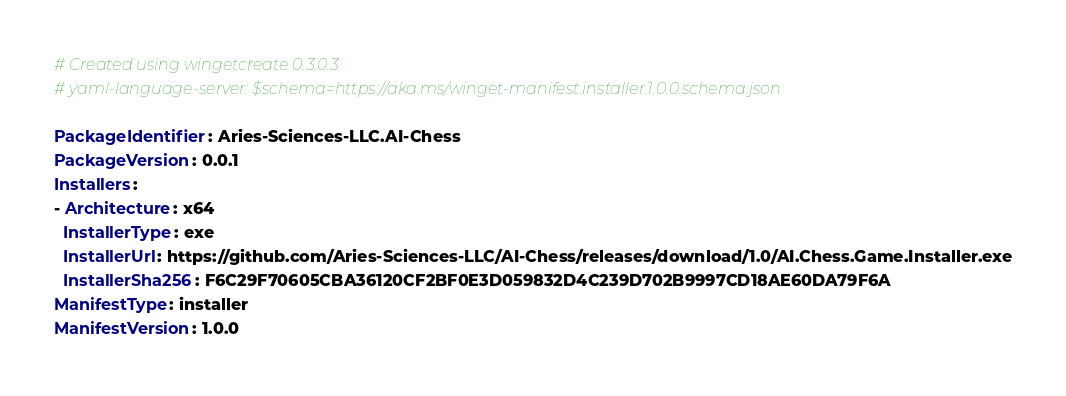Convert code to text. <code><loc_0><loc_0><loc_500><loc_500><_YAML_># Created using wingetcreate 0.3.0.3
# yaml-language-server: $schema=https://aka.ms/winget-manifest.installer.1.0.0.schema.json

PackageIdentifier: Aries-Sciences-LLC.AI-Chess
PackageVersion: 0.0.1
Installers:
- Architecture: x64
  InstallerType: exe
  InstallerUrl: https://github.com/Aries-Sciences-LLC/AI-Chess/releases/download/1.0/AI.Chess.Game.Installer.exe
  InstallerSha256: F6C29F70605CBA36120CF2BF0E3D059832D4C239D702B9997CD18AE60DA79F6A
ManifestType: installer
ManifestVersion: 1.0.0

</code> 